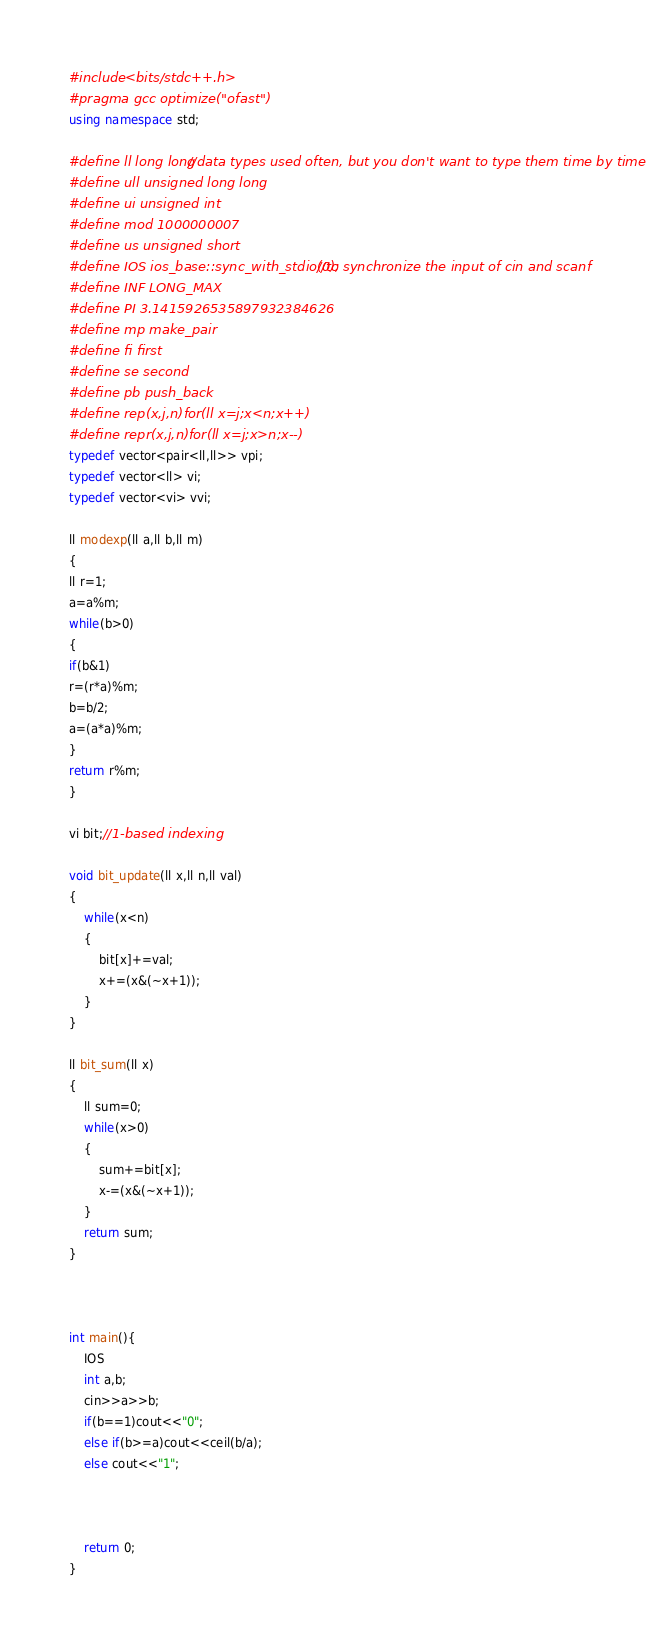Convert code to text. <code><loc_0><loc_0><loc_500><loc_500><_C++_>#include <bits/stdc++.h>
#pragma gcc optimize("ofast")
using namespace std;

#define ll long long //data types used often, but you don't want to type them time by time
#define ull unsigned long long
#define ui unsigned int
#define mod 1000000007
#define us unsigned short
#define IOS ios_base::sync_with_stdio(0); //to synchronize the input of cin and scanf
#define INF LONG_MAX
#define PI 3.1415926535897932384626
#define mp make_pair
#define fi first
#define se second
#define pb push_back
#define rep(x,j,n)for(ll x=j;x<n;x++)
#define repr(x,j,n)for(ll x=j;x>n;x--)
typedef vector<pair<ll,ll>> vpi;
typedef vector<ll> vi;
typedef vector<vi> vvi;

ll modexp(ll a,ll b,ll m)
{
ll r=1;
a=a%m;
while(b>0)
{
if(b&1)
r=(r*a)%m;
b=b/2;
a=(a*a)%m;
}
return r%m;
}

vi bit;//1-based indexing

void bit_update(ll x,ll n,ll val)
{
    while(x<n)
    {
        bit[x]+=val;
        x+=(x&(~x+1));
    }
}

ll bit_sum(ll x)
{
    ll sum=0;
    while(x>0)
    {
        sum+=bit[x];
        x-=(x&(~x+1));
    }
    return sum;
}



int main(){
    IOS
    int a,b;
    cin>>a>>b;
    if(b==1)cout<<"0";
    else if(b>=a)cout<<ceil(b/a);
    else cout<<"1";



    return 0;
}
</code> 